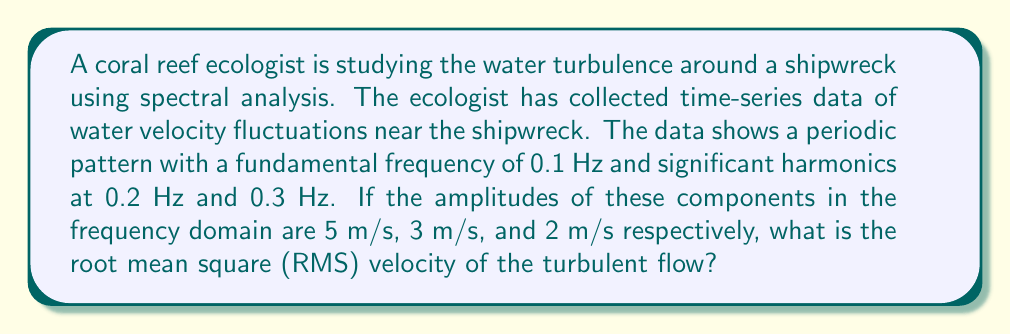Help me with this question. To solve this problem, we need to use Parseval's theorem, which relates the energy in the time domain to the energy in the frequency domain. For a discrete Fourier transform, this theorem states that the sum of the squared amplitudes in the frequency domain is proportional to the mean squared value in the time domain.

Let's approach this step-by-step:

1) First, we need to square the amplitudes of each frequency component:
   
   At 0.1 Hz: $5^2 = 25$ (m/s)²
   At 0.2 Hz: $3^2 = 9$ (m/s)²
   At 0.3 Hz: $2^2 = 4$ (m/s)²

2) Now, we sum these squared amplitudes:
   
   $25 + 9 + 4 = 38$ (m/s)²

3) This sum represents twice the mean squared velocity. To get the mean squared velocity, we divide by 2:
   
   Mean squared velocity = $\frac{38}{2} = 19$ (m/s)²

4) The root mean square (RMS) velocity is the square root of the mean squared velocity:
   
   RMS velocity = $\sqrt{19}$ m/s

5) Simplifying:
   
   RMS velocity $\approx 4.359$ m/s

Thus, the RMS velocity of the turbulent flow is approximately 4.359 m/s.
Answer: $4.359$ m/s 